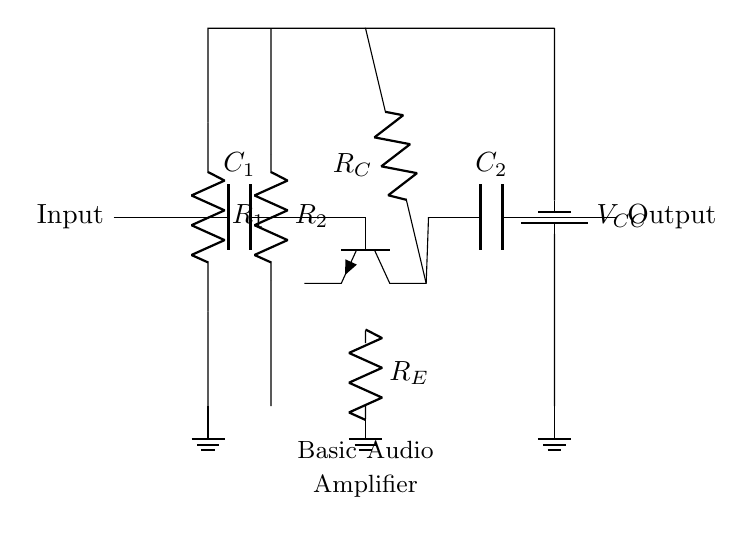What type of transistor is used in the circuit? The circuit shows an npn transistor, identifiable by the symbol in the diagram. Npn transistors have three terminals and are marked with an arrow indicating the current direction from the collector to the emitter.
Answer: npn What is the function of capacitor C1? Capacitor C1 acts as a coupling capacitor, allowing AC signals (the audio signals) to pass while blocking DC voltage, ensuring no DC offset is applied to the input signal.
Answer: Coupling What is the role of resistor R_E? Resistor R_E is an emitter resistor that stabilizes the biasing of the transistor by providing negative feedback. This helps maintain consistent performance despite variations in load or temperature.
Answer: Emitter stabilization What is the power supply voltage indicated in the circuit? The circuit indicates a battery labeled with V_CC, which is the power supply voltage. The label suggests a standard positive supply connection for the amplifier section of the circuit.
Answer: V_CC How are the input and output connected in this amplifier? The input is connected through capacitor C1, while the output is taken from capacitor C2. Both capacitors are used to allow only AC signals to pass, isolating the DC component of the signals.
Answer: Through capacitors What effect do resistors R1 and R2 have on the circuit? Resistors R1 and R2 form a voltage divider that creates a specific biasing voltage at the base of the transistor, influencing its operating point and ensuring proper amplification of the input signal.
Answer: Biasing voltage What does the output of the amplifier represent? The output of the amplifier represents an amplified version of the input audio signal, allowing for clearer voice recordings. This amplified signal can then be sent to speakers or further processing stages.
Answer: Amplified audio signal 